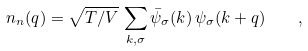Convert formula to latex. <formula><loc_0><loc_0><loc_500><loc_500>n _ { n } ( q ) = \sqrt { T / V } \, \sum _ { k , \sigma } \bar { \psi } _ { \sigma } ( k ) \, \psi _ { \sigma } ( k + q ) \quad ,</formula> 